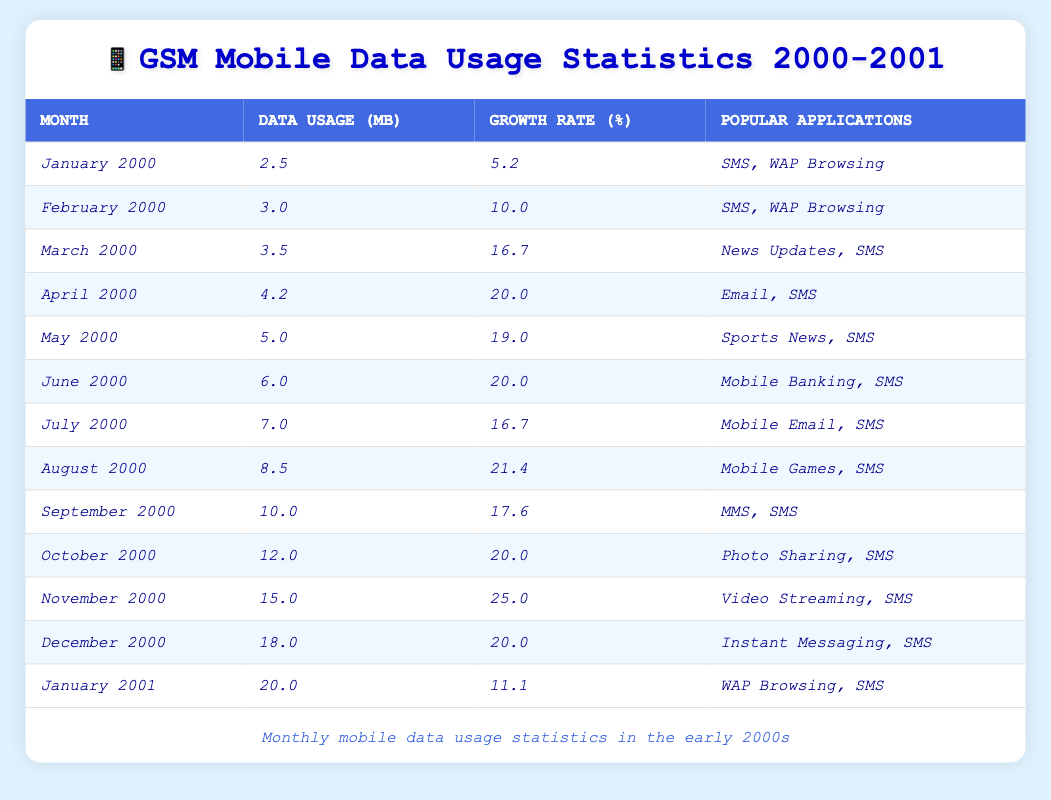What's the mobile data usage for December 2000? In the table, the row for December 2000 shows the mobile data usage listed as 18.0 MB.
Answer: 18.0 MB Which month had the highest average growth rate? By reviewing the growth rates in the table, November 2000 has the highest average growth rate of 25.0%.
Answer: November 2000 What is the total mobile data usage from January to June 2000? Adding the mobile data usage: (2.5 + 3.0 + 3.5 + 4.2 + 5.0 + 6.0) = 24.2 MB.
Answer: 24.2 MB Was there a month when popular applications included both Video Streaming and SMS? The table indicates that November 2000 has Video Streaming and SMS as popular applications listed.
Answer: Yes How much did mobile data usage increase from January to January of the following year? Mobile data usage in January 2001 is 20.0 MB, and in January 2000 it is 2.5 MB. The increase is calculated as 20.0 - 2.5 = 17.5 MB.
Answer: 17.5 MB What percentage growth did mobile data usage experience from May to June 2000? The mobile data usage in May 2000 is 5.0 MB, and in June 2000 it is 6.0 MB. The growth is (6.0 - 5.0) / 5.0 * 100 = 20%.
Answer: 20% Identify a month with more than 10 MB of mobile data usage and its applications. In October 2000, the mobile data usage is 12.0 MB, and the popular applications are Photo Sharing and SMS.
Answer: October 2000, Photo Sharing, SMS What is the average mobile data usage for the last three months of 2000? The data usage for October, November, and December is 12.0, 15.0, and 18.0 MB respectively. The average is (12.0 + 15.0 + 18.0) / 3 = 15.0 MB.
Answer: 15.0 MB Did SMS remain a popular application throughout the observed months? Yes, SMS appears in the list of popular applications for every month in the table.
Answer: Yes What was the increase in mobile data usage from August to September 2000? The data usage in August 2000 is 8.5 MB, and in September 2000 it is 10.0 MB. The increase is calculated as 10.0 - 8.5 = 1.5 MB.
Answer: 1.5 MB 